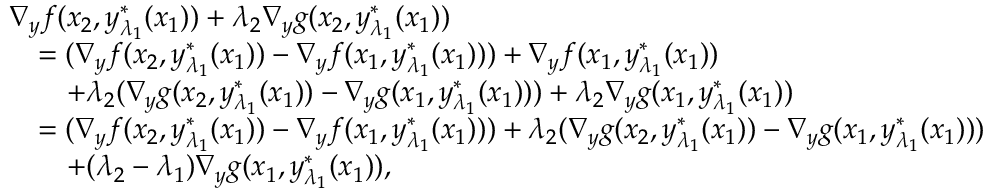<formula> <loc_0><loc_0><loc_500><loc_500>\begin{array} { r l } & { \nabla _ { y } f ( x _ { 2 } , y _ { \lambda _ { 1 } } ^ { * } ( x _ { 1 } ) ) + \lambda _ { 2 } \nabla _ { y } g ( x _ { 2 } , y _ { \lambda _ { 1 } } ^ { * } ( x _ { 1 } ) ) } \\ & { \quad = ( \nabla _ { y } f ( x _ { 2 } , y _ { \lambda _ { 1 } } ^ { * } ( x _ { 1 } ) ) - \nabla _ { y } f ( x _ { 1 } , y _ { \lambda _ { 1 } } ^ { * } ( x _ { 1 } ) ) ) + \nabla _ { y } f ( x _ { 1 } , y _ { \lambda _ { 1 } } ^ { * } ( x _ { 1 } ) ) } \\ & { \quad + \lambda _ { 2 } ( \nabla _ { y } g ( x _ { 2 } , y _ { \lambda _ { 1 } } ^ { * } ( x _ { 1 } ) ) - \nabla _ { y } g ( x _ { 1 } , y _ { \lambda _ { 1 } } ^ { * } ( x _ { 1 } ) ) ) + \lambda _ { 2 } \nabla _ { y } g ( x _ { 1 } , y _ { \lambda _ { 1 } } ^ { * } ( x _ { 1 } ) ) } \\ & { \quad = ( \nabla _ { y } f ( x _ { 2 } , y _ { \lambda _ { 1 } } ^ { * } ( x _ { 1 } ) ) - \nabla _ { y } f ( x _ { 1 } , y _ { \lambda _ { 1 } } ^ { * } ( x _ { 1 } ) ) ) + \lambda _ { 2 } ( \nabla _ { y } g ( x _ { 2 } , y _ { \lambda _ { 1 } } ^ { * } ( x _ { 1 } ) ) - \nabla _ { y } g ( x _ { 1 } , y _ { \lambda _ { 1 } } ^ { * } ( x _ { 1 } ) ) ) } \\ & { \quad + ( \lambda _ { 2 } - \lambda _ { 1 } ) \nabla _ { y } g ( x _ { 1 } , y _ { \lambda _ { 1 } } ^ { * } ( x _ { 1 } ) ) , } \end{array}</formula> 